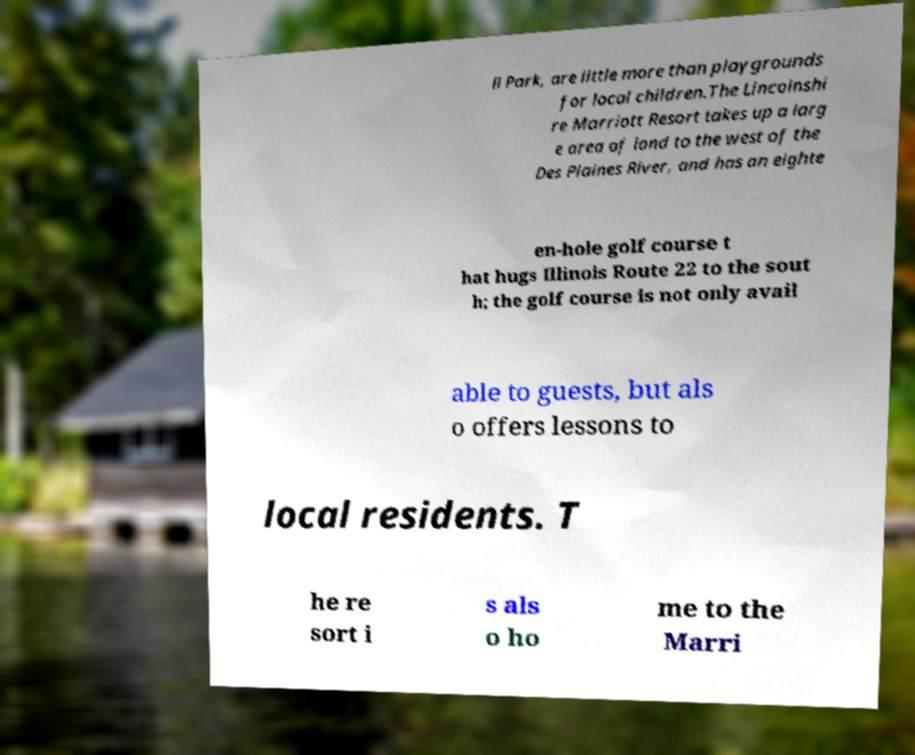Can you accurately transcribe the text from the provided image for me? ll Park, are little more than playgrounds for local children.The Lincolnshi re Marriott Resort takes up a larg e area of land to the west of the Des Plaines River, and has an eighte en-hole golf course t hat hugs Illinois Route 22 to the sout h; the golf course is not only avail able to guests, but als o offers lessons to local residents. T he re sort i s als o ho me to the Marri 